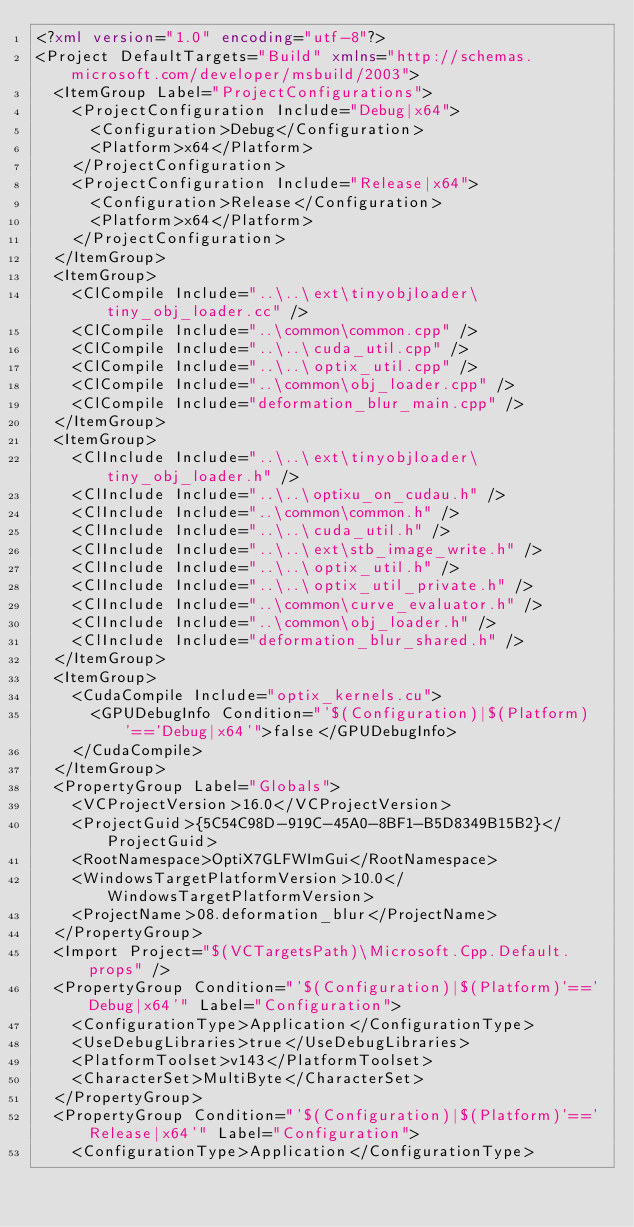<code> <loc_0><loc_0><loc_500><loc_500><_XML_><?xml version="1.0" encoding="utf-8"?>
<Project DefaultTargets="Build" xmlns="http://schemas.microsoft.com/developer/msbuild/2003">
  <ItemGroup Label="ProjectConfigurations">
    <ProjectConfiguration Include="Debug|x64">
      <Configuration>Debug</Configuration>
      <Platform>x64</Platform>
    </ProjectConfiguration>
    <ProjectConfiguration Include="Release|x64">
      <Configuration>Release</Configuration>
      <Platform>x64</Platform>
    </ProjectConfiguration>
  </ItemGroup>
  <ItemGroup>
    <ClCompile Include="..\..\ext\tinyobjloader\tiny_obj_loader.cc" />
    <ClCompile Include="..\common\common.cpp" />
    <ClCompile Include="..\..\cuda_util.cpp" />
    <ClCompile Include="..\..\optix_util.cpp" />
    <ClCompile Include="..\common\obj_loader.cpp" />
    <ClCompile Include="deformation_blur_main.cpp" />
  </ItemGroup>
  <ItemGroup>
    <ClInclude Include="..\..\ext\tinyobjloader\tiny_obj_loader.h" />
    <ClInclude Include="..\..\optixu_on_cudau.h" />
    <ClInclude Include="..\common\common.h" />
    <ClInclude Include="..\..\cuda_util.h" />
    <ClInclude Include="..\..\ext\stb_image_write.h" />
    <ClInclude Include="..\..\optix_util.h" />
    <ClInclude Include="..\..\optix_util_private.h" />
    <ClInclude Include="..\common\curve_evaluator.h" />
    <ClInclude Include="..\common\obj_loader.h" />
    <ClInclude Include="deformation_blur_shared.h" />
  </ItemGroup>
  <ItemGroup>
    <CudaCompile Include="optix_kernels.cu">
      <GPUDebugInfo Condition="'$(Configuration)|$(Platform)'=='Debug|x64'">false</GPUDebugInfo>
    </CudaCompile>
  </ItemGroup>
  <PropertyGroup Label="Globals">
    <VCProjectVersion>16.0</VCProjectVersion>
    <ProjectGuid>{5C54C98D-919C-45A0-8BF1-B5D8349B15B2}</ProjectGuid>
    <RootNamespace>OptiX7GLFWImGui</RootNamespace>
    <WindowsTargetPlatformVersion>10.0</WindowsTargetPlatformVersion>
    <ProjectName>08.deformation_blur</ProjectName>
  </PropertyGroup>
  <Import Project="$(VCTargetsPath)\Microsoft.Cpp.Default.props" />
  <PropertyGroup Condition="'$(Configuration)|$(Platform)'=='Debug|x64'" Label="Configuration">
    <ConfigurationType>Application</ConfigurationType>
    <UseDebugLibraries>true</UseDebugLibraries>
    <PlatformToolset>v143</PlatformToolset>
    <CharacterSet>MultiByte</CharacterSet>
  </PropertyGroup>
  <PropertyGroup Condition="'$(Configuration)|$(Platform)'=='Release|x64'" Label="Configuration">
    <ConfigurationType>Application</ConfigurationType></code> 